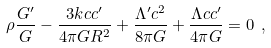<formula> <loc_0><loc_0><loc_500><loc_500>\rho \frac { G ^ { \prime } } { G } - \frac { 3 k c c ^ { \prime } } { 4 \pi G R ^ { 2 } } + \frac { \Lambda ^ { \prime } c ^ { 2 } } { 8 \pi G } + \frac { \Lambda c c ^ { \prime } } { 4 \pi G } = 0 \ ,</formula> 